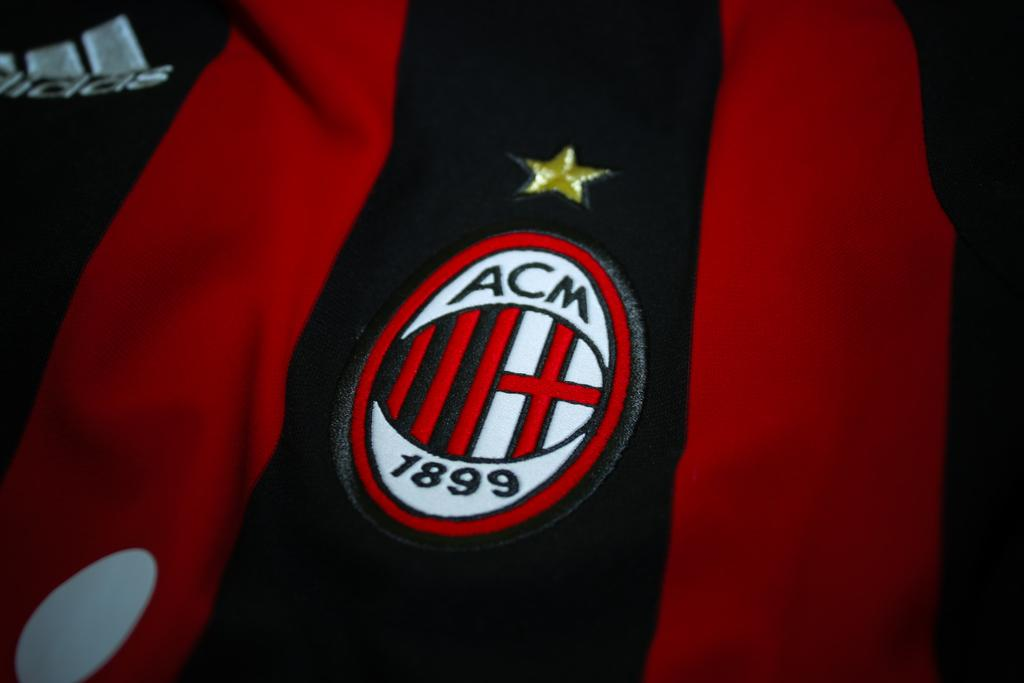What is present in the image that has a design or pattern? There is a cloth in the image that has a logo and a star. Can you describe the logo on the cloth? Unfortunately, the specific details of the logo cannot be determined from the provided facts. What shape is present on the cloth? The cloth has a star. What type of structure can be seen in the background of the image? There is no structure visible in the image; it only features a cloth with a logo and a star. Is there any grass present in the image? There is no grass present in the image; it only features a cloth with a logo and a star. 